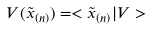<formula> <loc_0><loc_0><loc_500><loc_500>V ( \tilde { x } _ { ( n ) } ) = < \tilde { x } _ { ( n ) } | V ></formula> 